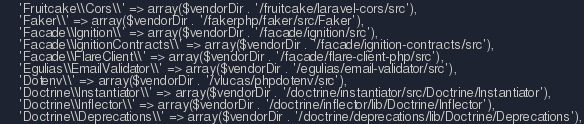Convert code to text. <code><loc_0><loc_0><loc_500><loc_500><_PHP_>    'Fruitcake\\Cors\\' => array($vendorDir . '/fruitcake/laravel-cors/src'),
    'Faker\\' => array($vendorDir . '/fakerphp/faker/src/Faker'),
    'Facade\\Ignition\\' => array($vendorDir . '/facade/ignition/src'),
    'Facade\\IgnitionContracts\\' => array($vendorDir . '/facade/ignition-contracts/src'),
    'Facade\\FlareClient\\' => array($vendorDir . '/facade/flare-client-php/src'),
    'Egulias\\EmailValidator\\' => array($vendorDir . '/egulias/email-validator/src'),
    'Dotenv\\' => array($vendorDir . '/vlucas/phpdotenv/src'),
    'Doctrine\\Instantiator\\' => array($vendorDir . '/doctrine/instantiator/src/Doctrine/Instantiator'),
    'Doctrine\\Inflector\\' => array($vendorDir . '/doctrine/inflector/lib/Doctrine/Inflector'),
    'Doctrine\\Deprecations\\' => array($vendorDir . '/doctrine/deprecations/lib/Doctrine/Deprecations'),</code> 